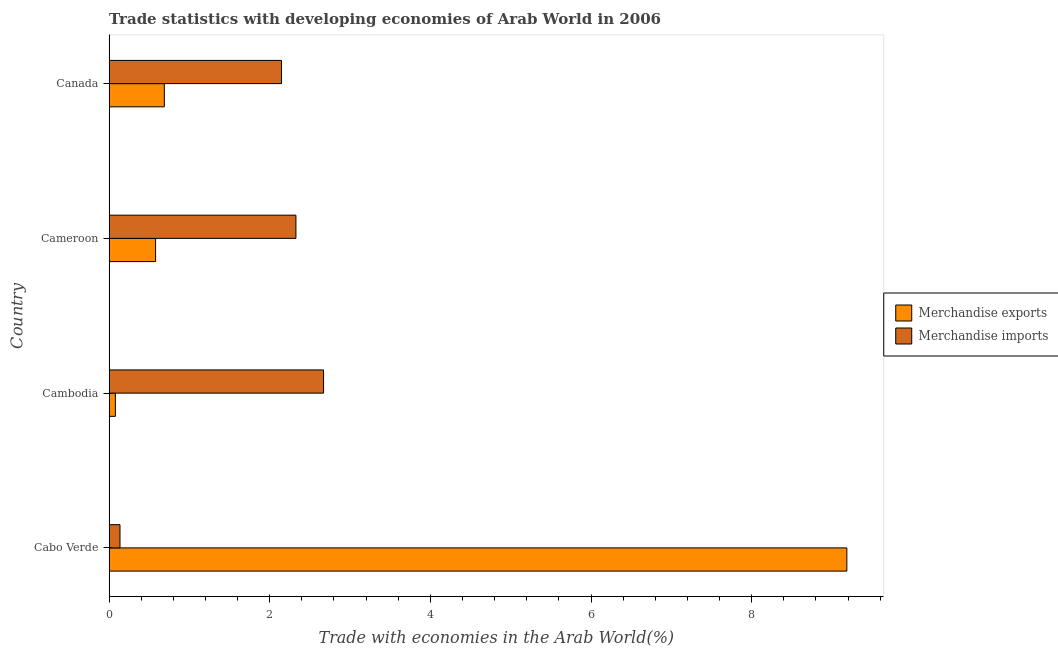How many different coloured bars are there?
Offer a terse response. 2. How many groups of bars are there?
Provide a succinct answer. 4. How many bars are there on the 3rd tick from the bottom?
Your answer should be very brief. 2. What is the label of the 2nd group of bars from the top?
Your answer should be compact. Cameroon. In how many cases, is the number of bars for a given country not equal to the number of legend labels?
Make the answer very short. 0. What is the merchandise imports in Cameroon?
Keep it short and to the point. 2.33. Across all countries, what is the maximum merchandise imports?
Ensure brevity in your answer.  2.67. Across all countries, what is the minimum merchandise imports?
Provide a short and direct response. 0.14. In which country was the merchandise exports maximum?
Keep it short and to the point. Cabo Verde. In which country was the merchandise exports minimum?
Keep it short and to the point. Cambodia. What is the total merchandise imports in the graph?
Provide a short and direct response. 7.28. What is the difference between the merchandise imports in Cambodia and that in Cameroon?
Your answer should be very brief. 0.34. What is the difference between the merchandise exports in Cambodia and the merchandise imports in Cabo Verde?
Ensure brevity in your answer.  -0.06. What is the average merchandise imports per country?
Your response must be concise. 1.82. What is the difference between the merchandise imports and merchandise exports in Cameroon?
Provide a short and direct response. 1.75. What is the ratio of the merchandise exports in Cabo Verde to that in Cameroon?
Provide a succinct answer. 15.86. Is the merchandise imports in Cameroon less than that in Canada?
Make the answer very short. No. Is the difference between the merchandise exports in Cameroon and Canada greater than the difference between the merchandise imports in Cameroon and Canada?
Ensure brevity in your answer.  No. What is the difference between the highest and the second highest merchandise exports?
Offer a very short reply. 8.5. What is the difference between the highest and the lowest merchandise imports?
Keep it short and to the point. 2.53. In how many countries, is the merchandise exports greater than the average merchandise exports taken over all countries?
Offer a terse response. 1. What does the 2nd bar from the top in Cambodia represents?
Make the answer very short. Merchandise exports. Are all the bars in the graph horizontal?
Your response must be concise. Yes. What is the difference between two consecutive major ticks on the X-axis?
Offer a terse response. 2. Are the values on the major ticks of X-axis written in scientific E-notation?
Offer a terse response. No. Does the graph contain any zero values?
Make the answer very short. No. Does the graph contain grids?
Provide a short and direct response. No. How are the legend labels stacked?
Your answer should be very brief. Vertical. What is the title of the graph?
Give a very brief answer. Trade statistics with developing economies of Arab World in 2006. Does "Commercial service imports" appear as one of the legend labels in the graph?
Keep it short and to the point. No. What is the label or title of the X-axis?
Your answer should be very brief. Trade with economies in the Arab World(%). What is the Trade with economies in the Arab World(%) in Merchandise exports in Cabo Verde?
Your answer should be compact. 9.18. What is the Trade with economies in the Arab World(%) of Merchandise imports in Cabo Verde?
Your answer should be compact. 0.14. What is the Trade with economies in the Arab World(%) in Merchandise exports in Cambodia?
Keep it short and to the point. 0.08. What is the Trade with economies in the Arab World(%) of Merchandise imports in Cambodia?
Keep it short and to the point. 2.67. What is the Trade with economies in the Arab World(%) of Merchandise exports in Cameroon?
Provide a short and direct response. 0.58. What is the Trade with economies in the Arab World(%) of Merchandise imports in Cameroon?
Keep it short and to the point. 2.33. What is the Trade with economies in the Arab World(%) in Merchandise exports in Canada?
Make the answer very short. 0.69. What is the Trade with economies in the Arab World(%) in Merchandise imports in Canada?
Keep it short and to the point. 2.15. Across all countries, what is the maximum Trade with economies in the Arab World(%) in Merchandise exports?
Provide a succinct answer. 9.18. Across all countries, what is the maximum Trade with economies in the Arab World(%) in Merchandise imports?
Give a very brief answer. 2.67. Across all countries, what is the minimum Trade with economies in the Arab World(%) in Merchandise exports?
Offer a terse response. 0.08. Across all countries, what is the minimum Trade with economies in the Arab World(%) of Merchandise imports?
Provide a succinct answer. 0.14. What is the total Trade with economies in the Arab World(%) in Merchandise exports in the graph?
Keep it short and to the point. 10.53. What is the total Trade with economies in the Arab World(%) of Merchandise imports in the graph?
Your response must be concise. 7.28. What is the difference between the Trade with economies in the Arab World(%) of Merchandise exports in Cabo Verde and that in Cambodia?
Make the answer very short. 9.11. What is the difference between the Trade with economies in the Arab World(%) of Merchandise imports in Cabo Verde and that in Cambodia?
Keep it short and to the point. -2.53. What is the difference between the Trade with economies in the Arab World(%) of Merchandise exports in Cabo Verde and that in Cameroon?
Your answer should be very brief. 8.61. What is the difference between the Trade with economies in the Arab World(%) in Merchandise imports in Cabo Verde and that in Cameroon?
Keep it short and to the point. -2.19. What is the difference between the Trade with economies in the Arab World(%) in Merchandise exports in Cabo Verde and that in Canada?
Your answer should be very brief. 8.5. What is the difference between the Trade with economies in the Arab World(%) in Merchandise imports in Cabo Verde and that in Canada?
Provide a short and direct response. -2.01. What is the difference between the Trade with economies in the Arab World(%) of Merchandise exports in Cambodia and that in Cameroon?
Ensure brevity in your answer.  -0.5. What is the difference between the Trade with economies in the Arab World(%) of Merchandise imports in Cambodia and that in Cameroon?
Provide a succinct answer. 0.34. What is the difference between the Trade with economies in the Arab World(%) of Merchandise exports in Cambodia and that in Canada?
Offer a terse response. -0.61. What is the difference between the Trade with economies in the Arab World(%) in Merchandise imports in Cambodia and that in Canada?
Your answer should be compact. 0.52. What is the difference between the Trade with economies in the Arab World(%) in Merchandise exports in Cameroon and that in Canada?
Keep it short and to the point. -0.11. What is the difference between the Trade with economies in the Arab World(%) of Merchandise imports in Cameroon and that in Canada?
Provide a succinct answer. 0.18. What is the difference between the Trade with economies in the Arab World(%) of Merchandise exports in Cabo Verde and the Trade with economies in the Arab World(%) of Merchandise imports in Cambodia?
Your answer should be compact. 6.51. What is the difference between the Trade with economies in the Arab World(%) of Merchandise exports in Cabo Verde and the Trade with economies in the Arab World(%) of Merchandise imports in Cameroon?
Your answer should be compact. 6.86. What is the difference between the Trade with economies in the Arab World(%) in Merchandise exports in Cabo Verde and the Trade with economies in the Arab World(%) in Merchandise imports in Canada?
Provide a short and direct response. 7.04. What is the difference between the Trade with economies in the Arab World(%) of Merchandise exports in Cambodia and the Trade with economies in the Arab World(%) of Merchandise imports in Cameroon?
Your answer should be compact. -2.25. What is the difference between the Trade with economies in the Arab World(%) in Merchandise exports in Cambodia and the Trade with economies in the Arab World(%) in Merchandise imports in Canada?
Provide a short and direct response. -2.07. What is the difference between the Trade with economies in the Arab World(%) in Merchandise exports in Cameroon and the Trade with economies in the Arab World(%) in Merchandise imports in Canada?
Give a very brief answer. -1.57. What is the average Trade with economies in the Arab World(%) in Merchandise exports per country?
Offer a very short reply. 2.63. What is the average Trade with economies in the Arab World(%) of Merchandise imports per country?
Offer a very short reply. 1.82. What is the difference between the Trade with economies in the Arab World(%) of Merchandise exports and Trade with economies in the Arab World(%) of Merchandise imports in Cabo Verde?
Offer a terse response. 9.05. What is the difference between the Trade with economies in the Arab World(%) of Merchandise exports and Trade with economies in the Arab World(%) of Merchandise imports in Cambodia?
Make the answer very short. -2.59. What is the difference between the Trade with economies in the Arab World(%) in Merchandise exports and Trade with economies in the Arab World(%) in Merchandise imports in Cameroon?
Ensure brevity in your answer.  -1.75. What is the difference between the Trade with economies in the Arab World(%) in Merchandise exports and Trade with economies in the Arab World(%) in Merchandise imports in Canada?
Provide a succinct answer. -1.46. What is the ratio of the Trade with economies in the Arab World(%) in Merchandise exports in Cabo Verde to that in Cambodia?
Provide a succinct answer. 116.87. What is the ratio of the Trade with economies in the Arab World(%) of Merchandise imports in Cabo Verde to that in Cambodia?
Give a very brief answer. 0.05. What is the ratio of the Trade with economies in the Arab World(%) of Merchandise exports in Cabo Verde to that in Cameroon?
Give a very brief answer. 15.86. What is the ratio of the Trade with economies in the Arab World(%) in Merchandise imports in Cabo Verde to that in Cameroon?
Make the answer very short. 0.06. What is the ratio of the Trade with economies in the Arab World(%) of Merchandise exports in Cabo Verde to that in Canada?
Provide a short and direct response. 13.35. What is the ratio of the Trade with economies in the Arab World(%) in Merchandise imports in Cabo Verde to that in Canada?
Provide a succinct answer. 0.06. What is the ratio of the Trade with economies in the Arab World(%) of Merchandise exports in Cambodia to that in Cameroon?
Keep it short and to the point. 0.14. What is the ratio of the Trade with economies in the Arab World(%) in Merchandise imports in Cambodia to that in Cameroon?
Provide a succinct answer. 1.15. What is the ratio of the Trade with economies in the Arab World(%) of Merchandise exports in Cambodia to that in Canada?
Provide a succinct answer. 0.11. What is the ratio of the Trade with economies in the Arab World(%) of Merchandise imports in Cambodia to that in Canada?
Your response must be concise. 1.24. What is the ratio of the Trade with economies in the Arab World(%) in Merchandise exports in Cameroon to that in Canada?
Provide a succinct answer. 0.84. What is the ratio of the Trade with economies in the Arab World(%) of Merchandise imports in Cameroon to that in Canada?
Ensure brevity in your answer.  1.08. What is the difference between the highest and the second highest Trade with economies in the Arab World(%) in Merchandise exports?
Give a very brief answer. 8.5. What is the difference between the highest and the second highest Trade with economies in the Arab World(%) of Merchandise imports?
Ensure brevity in your answer.  0.34. What is the difference between the highest and the lowest Trade with economies in the Arab World(%) in Merchandise exports?
Offer a very short reply. 9.11. What is the difference between the highest and the lowest Trade with economies in the Arab World(%) in Merchandise imports?
Give a very brief answer. 2.53. 